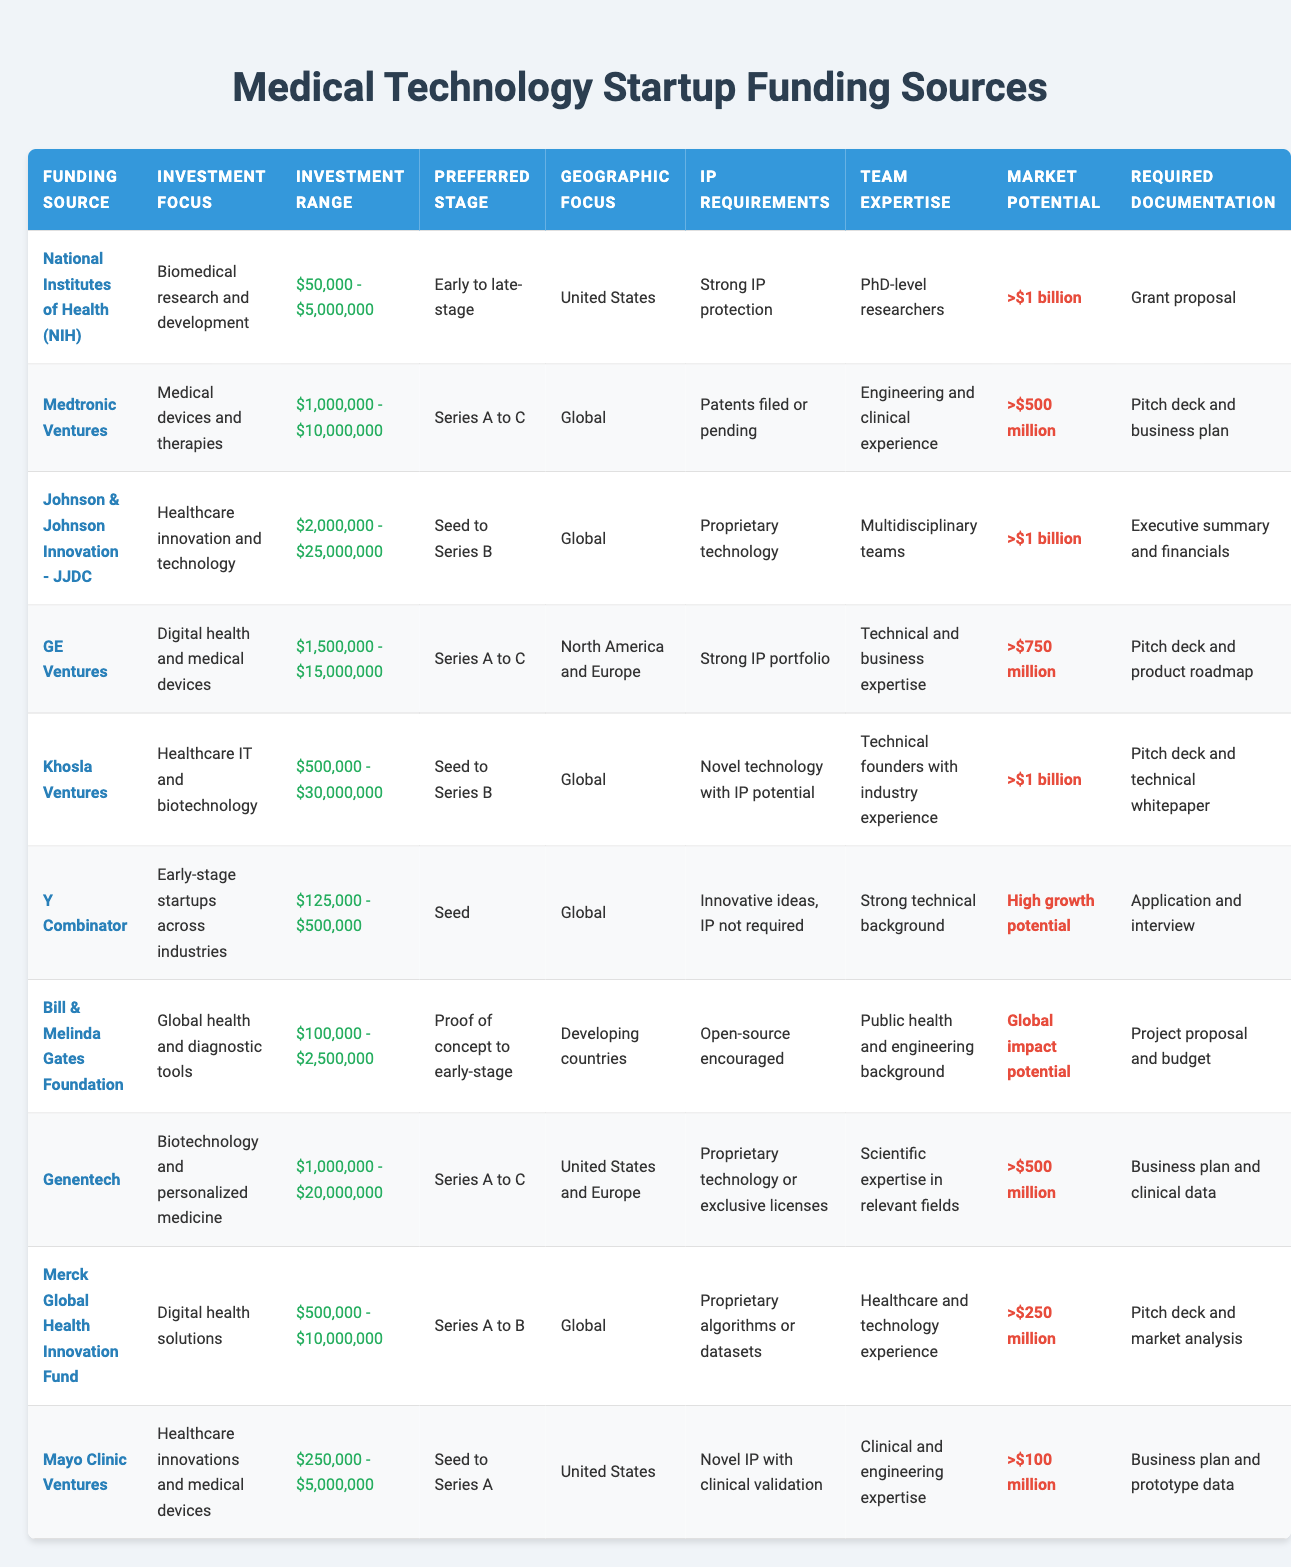What is the minimum investment required by Khosla Ventures? The table shows that the minimum investment required by Khosla Ventures is $500,000.
Answer: $500,000 Which funding source focuses on global health and diagnostic tools? The table lists the Bill & Melinda Gates Foundation as the funding source that focuses on global health and diagnostic tools.
Answer: Bill & Melinda Gates Foundation What is the investment range for Johnson & Johnson Innovation - JJDC? The minimum investment for Johnson & Johnson Innovation - JJDC is $2,000,000 and the maximum is $25,000,000; therefore, the investment range is $2,000,000 - $25,000,000.
Answer: $2,000,000 - $25,000,000 Does Mayo Clinic Ventures require strong IP protection? The table indicates that Mayo Clinic Ventures requires novel IP with clinical validation; thus, it does not specifically require strong IP protection.
Answer: No Which funding source has a geographic focus on developing countries? According to the table, the Bill & Melinda Gates Foundation has a geographic focus on developing countries.
Answer: Bill & Melinda Gates Foundation What is the total minimum investment required by the funding sources that focus on digital health? The funding sources focusing on digital health are GE Ventures and Mayo Clinic Ventures, with minimum investments of $1,500,000 and $250,000, respectively. Summing these gives: $1,500,000 + $250,000 = $1,750,000.
Answer: $1,750,000 Are there any funding sources that do not require IP? The table states that Y Combinator allows innovative ideas where IP is not required, confirming that there is at least one source that does not require IP.
Answer: Yes What is the preferred stage of funding for most sources? By reviewing the preferred stages listed, most sources target early to late-stage or Series A to C, indicating a common preference for these stages.
Answer: Early to late-stage or Series A to C Which funding source has the highest market potential over $1 billion? The funding sources with a market potential greater than $1 billion are NIH, Khosla Ventures, and Mayo Clinic Ventures, making them tied for the highest potential.
Answer: NIH, Khosla Ventures, and Mayo Clinic Ventures What documentation is required by GE Ventures? The required documentation for GE Ventures is a pitch deck and product roadmap, as per the table.
Answer: Pitch deck and product roadmap 